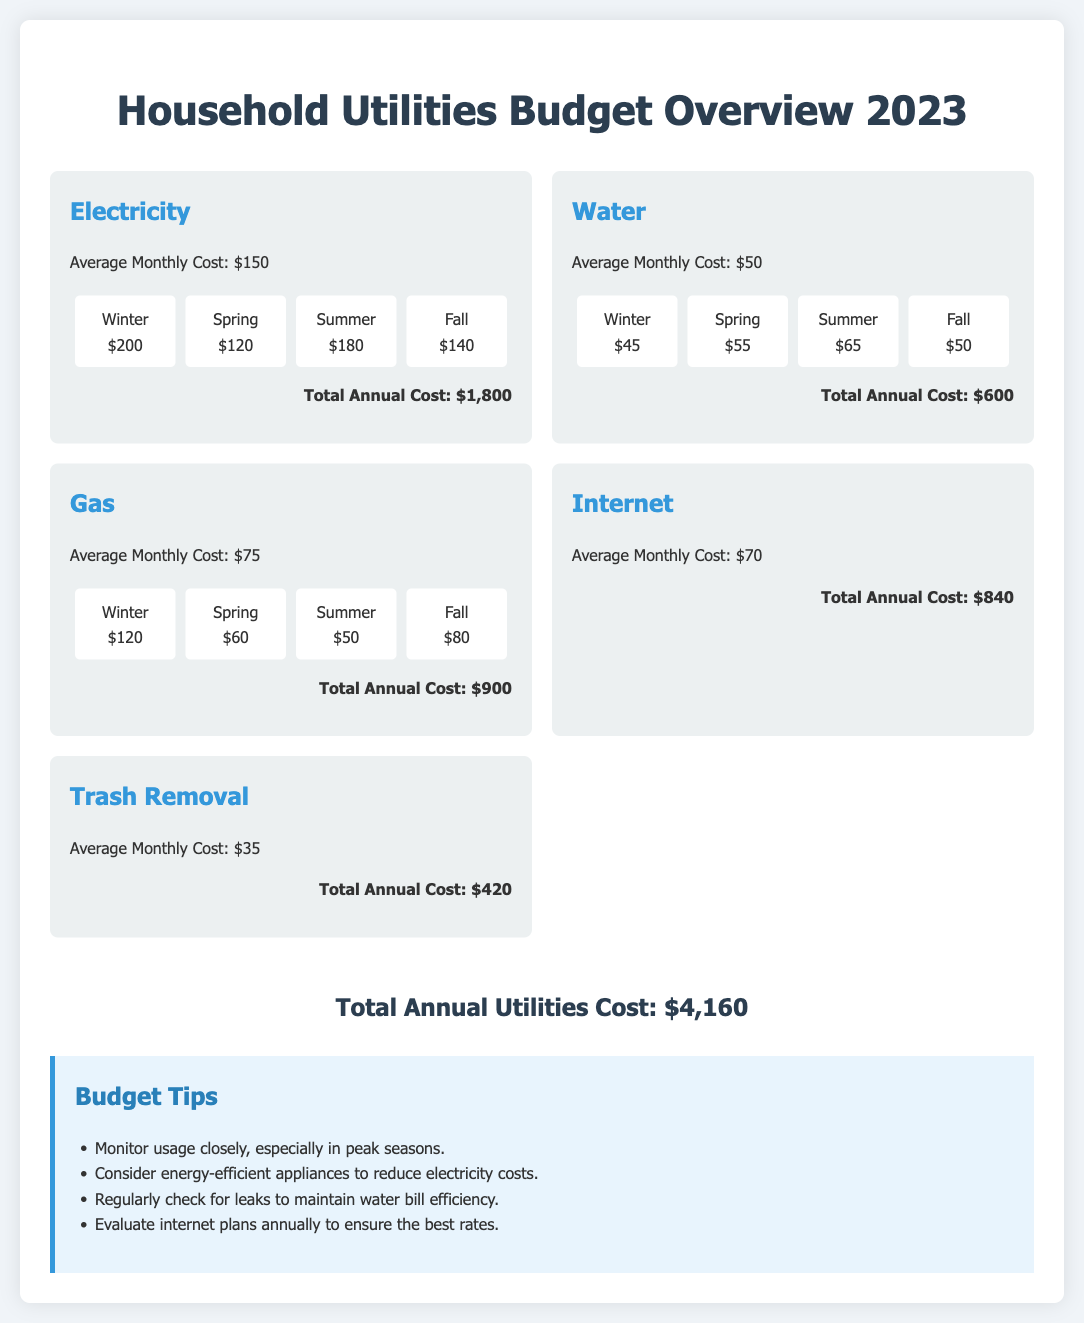What is the total annual cost for electricity? The total annual cost for electricity is provided at the bottom of the electricity section in the document.
Answer: $1,800 What is the average monthly cost of water? The average monthly cost of water is directly listed in the water utility card.
Answer: $50 Which season has the highest gas cost? The seasons' gas costs indicate winter has the highest cost, as noted in the seasonal variations.
Answer: Winter What is the total annual utilities cost? The total annual utilities cost sums all utility costs as shown at the bottom of the document.
Answer: $4,160 How much is the average monthly cost for internet? The average monthly cost for internet can be found in the internet utility card.
Answer: $70 What is one suggested budget tip related to water bills? A specific tip can be found in the budget tips section, focusing on maintenance practices for the water utility.
Answer: Regularly check for leaks What is the total cost for trash removal? The total cost for trash removal is found in the trash removal utility card in the document.
Answer: $420 Which utility has the lowest total annual cost? The total annual costs of all utilities can be compared directly in the utility cards.
Answer: Trash Removal What is the average cost of gas during spring? The spring gas cost is highlighted in the gas utility card's seasonal variations.
Answer: $60 